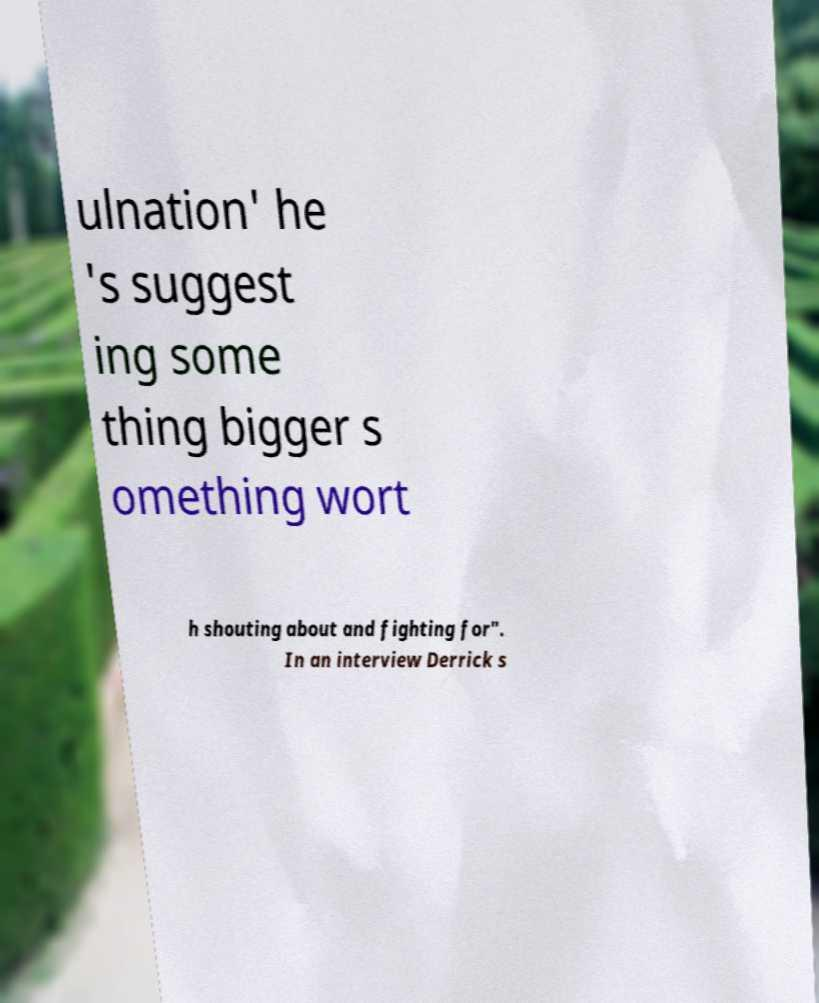What messages or text are displayed in this image? I need them in a readable, typed format. ulnation' he 's suggest ing some thing bigger s omething wort h shouting about and fighting for". In an interview Derrick s 